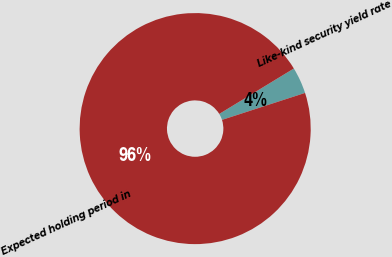<chart> <loc_0><loc_0><loc_500><loc_500><pie_chart><fcel>Like-kind security yield rate<fcel>Expected holding period in<nl><fcel>3.71%<fcel>96.29%<nl></chart> 